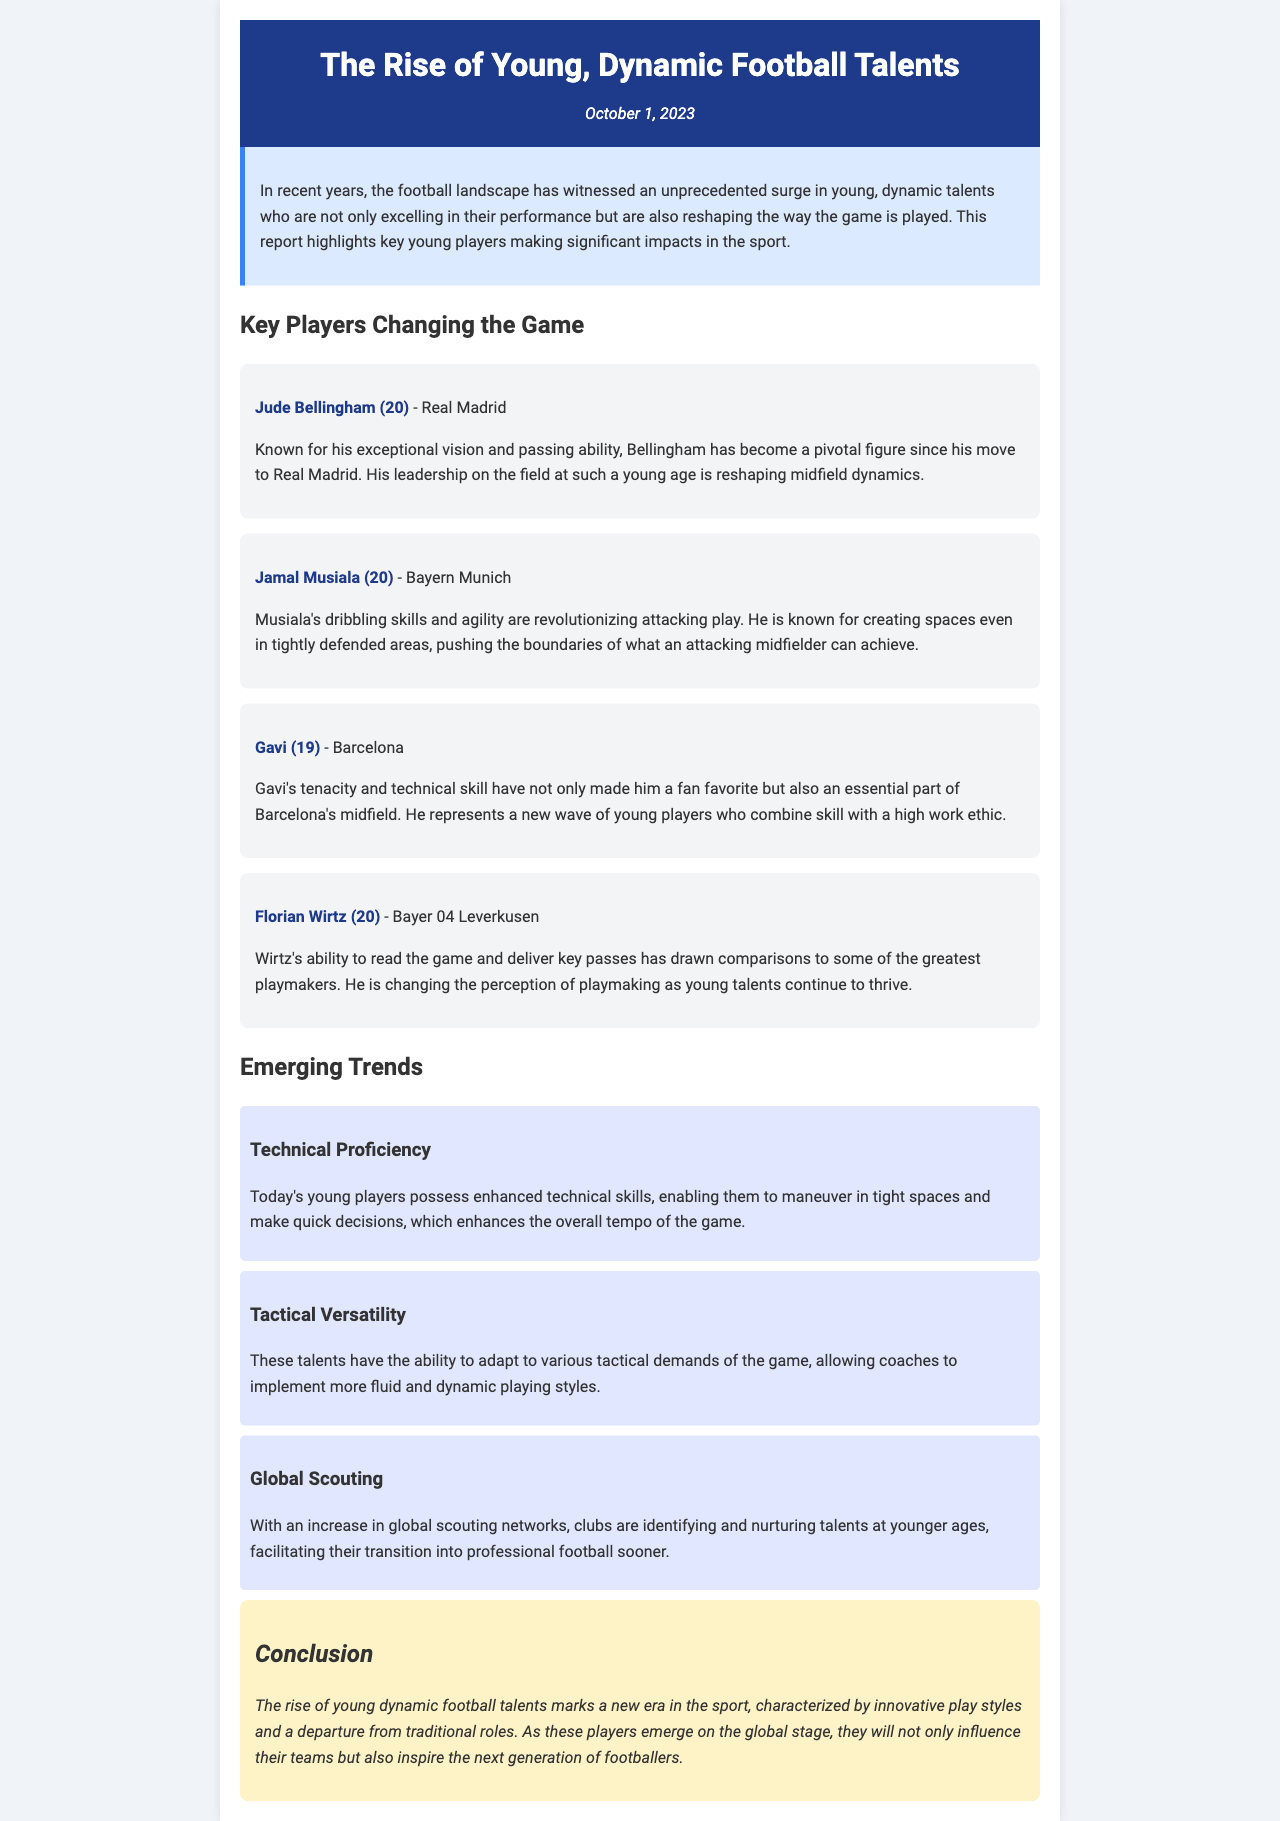what is the title of the report? The title of the report is prominently displayed at the top of the document.
Answer: The Rise of Young, Dynamic Football Talents who is the first player mentioned in the report? The player is highlighted in the section about key players changing the game.
Answer: Jude Bellingham how old is Gavi? The age of Gavi is provided alongside his name in the player card.
Answer: 19 which player plays for Bayern Munich? The player associated with Bayern Munich is mentioned in the key players section.
Answer: Jamal Musiala what is a key emerging trend in young football talents? The trends section lists various characteristics of today's young players, with one highlighted example.
Answer: Technical Proficiency how does the rise of young players affect coaching tactics? The document discusses the adaptability of young players in the context of tactical demands.
Answer: Tactical Versatility what date was the report published? The date of publication is clearly stated in the header section of the report.
Answer: October 1, 2023 what is a characteristic of Florian Wirtz mentioned in the report? The characteristic is described in the context of his playing style and contributions to the game.
Answer: Ability to read the game how does the report categorize the young talents? The report provides an overarching theme for the young talents discussed within.
Answer: Dynamic football talents 